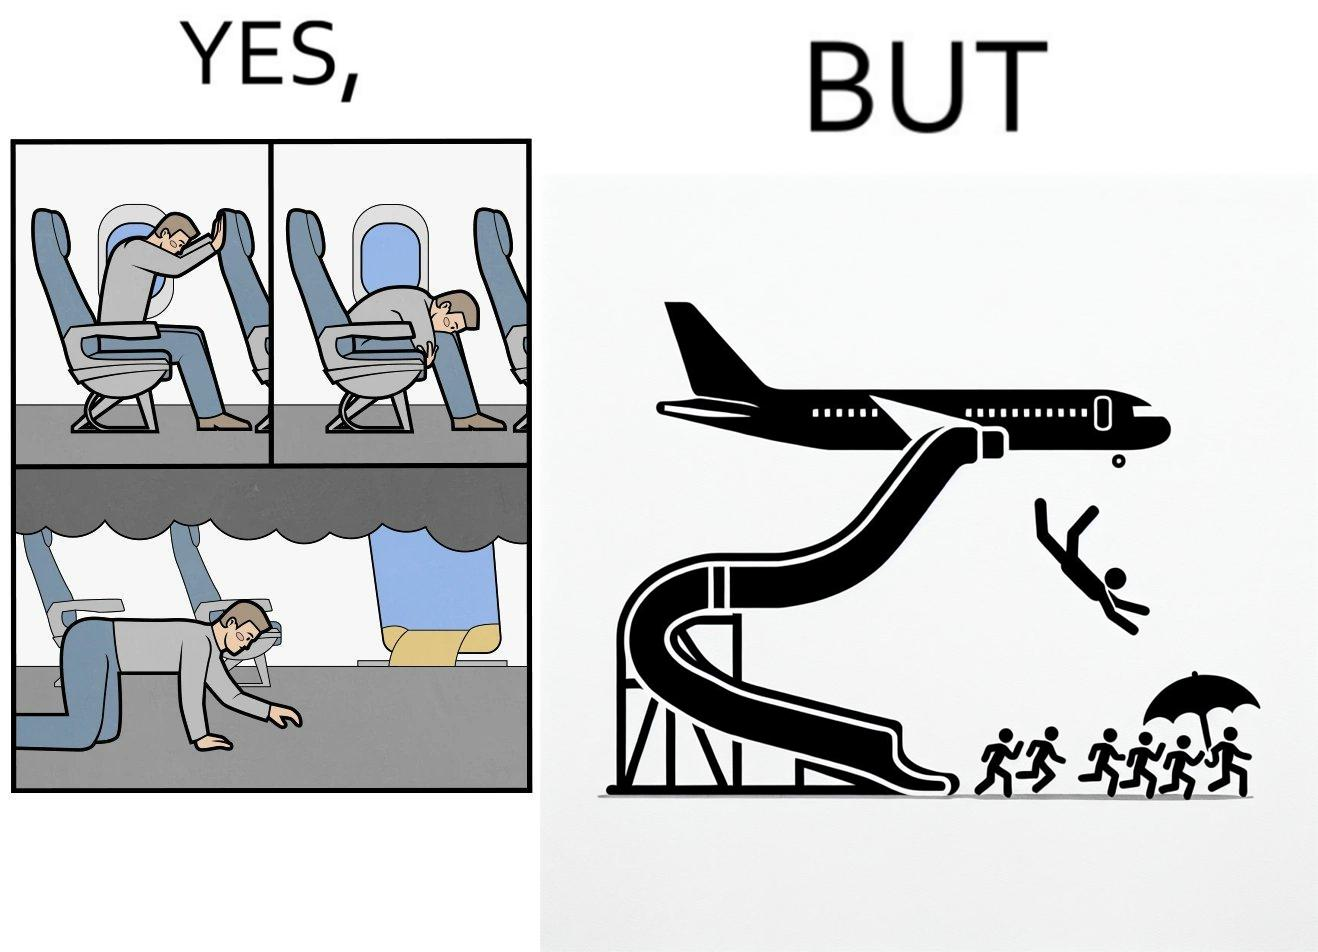Describe the satirical element in this image. These images are funny since it shows how we are taught emergency procedures to follow in case of an accident while in an airplane but how none of them work if the plane is still in air 